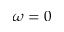<formula> <loc_0><loc_0><loc_500><loc_500>\omega = 0</formula> 